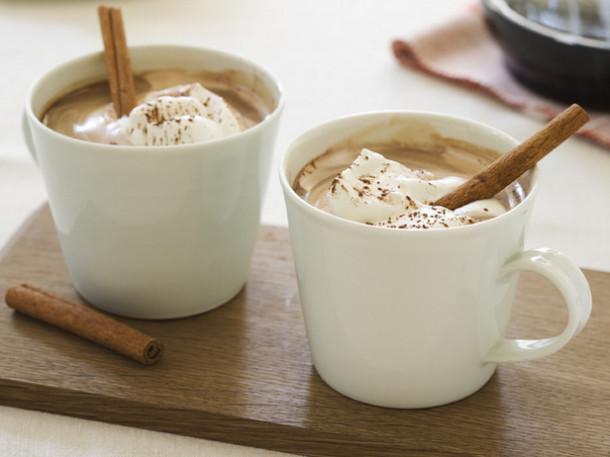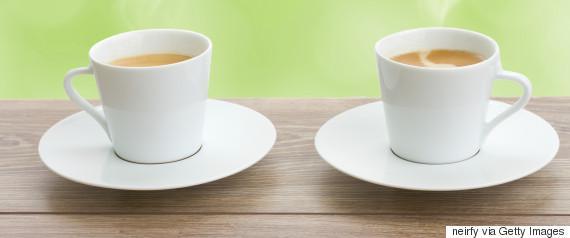The first image is the image on the left, the second image is the image on the right. Examine the images to the left and right. Is the description "Two white cups sit on saucers on a wooden table." accurate? Answer yes or no. Yes. The first image is the image on the left, the second image is the image on the right. For the images shown, is this caption "At least one image shows a pair of filled cups with silver spoons nearby." true? Answer yes or no. No. 